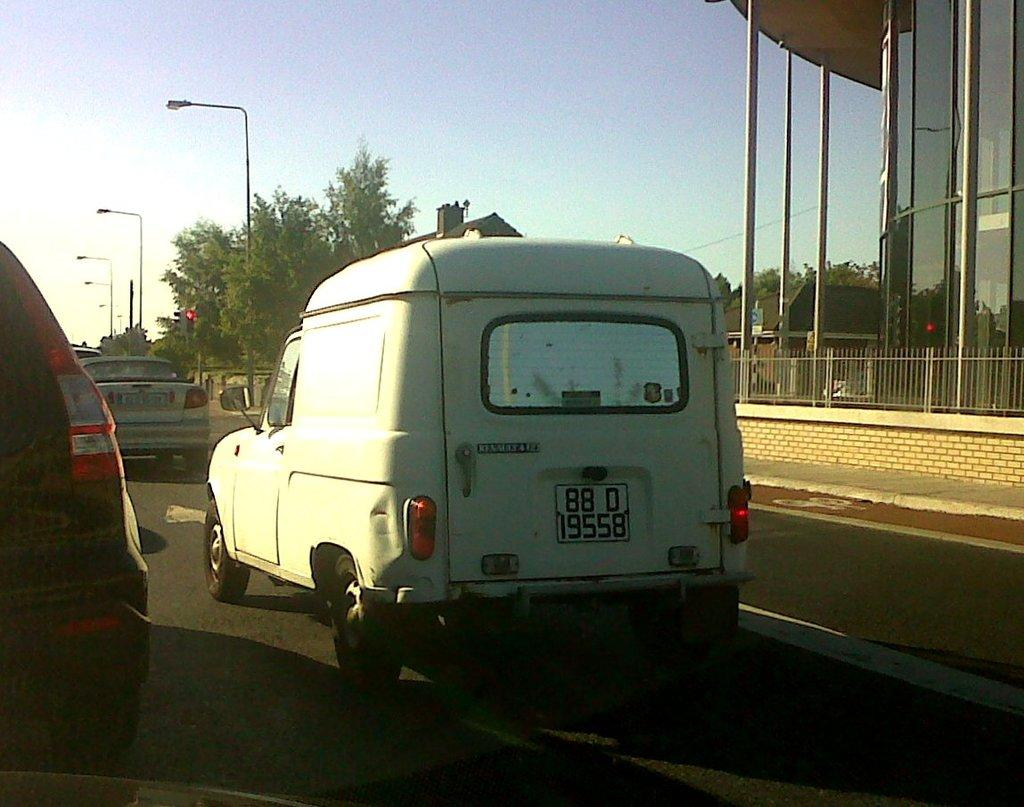What is happening on the road in the image? There are vehicles moving on the road in the image. What structures can be seen in the image? There are buildings visible in the image. What type of vegetation is present in the image? There are trees present in the image. What type of hate can be seen in the image? There is no hate present in the image; it features vehicles moving on the road, buildings, and trees. What type of lead is being used by the vehicles in the image? There is no information about the type of lead used by the vehicles in the image. 